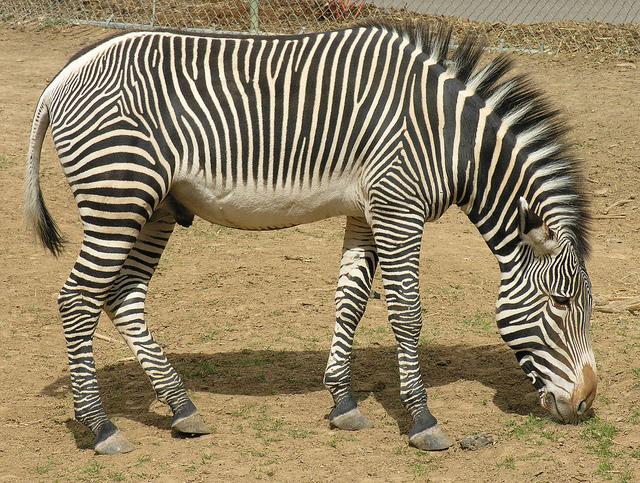What is on the zebra's neck?
Keep it brief. Stripes. Is the zebra eating grass?
Keep it brief. Yes. Is this a horse?
Give a very brief answer. No. Is the zebra sad?
Short answer required. No. 